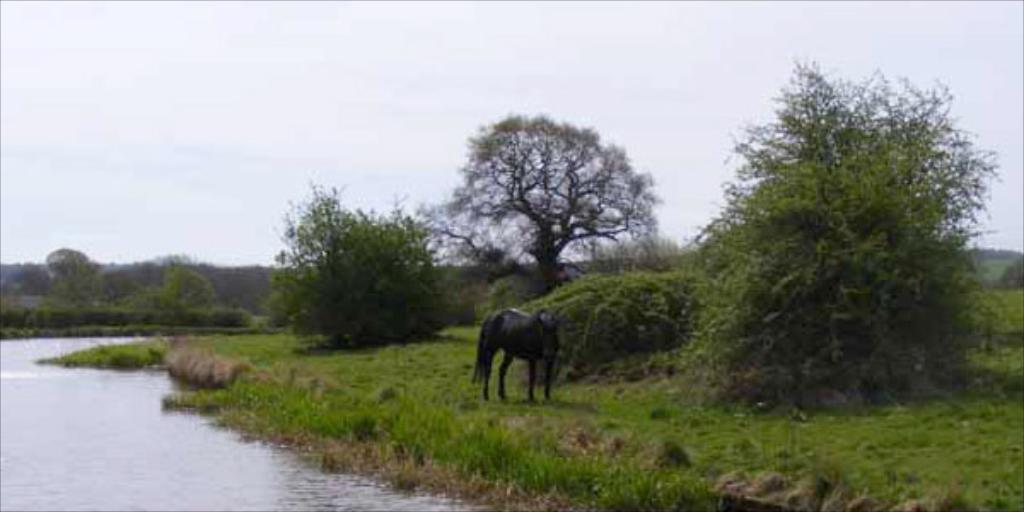What animal is standing on the ground in the image? There is a horse standing on the ground in the image. What can be seen on the left side of the image? There is water visible on the left side of the image. What type of vegetation is visible in the background of the image? There are trees in the background of the image. What is visible in the sky in the background of the image? The sky is visible in the background of the image. What type of vessel is being used to transport the seed in the image? There is no vessel or seed present in the image; it features a horse standing near water with trees and sky in the background. 